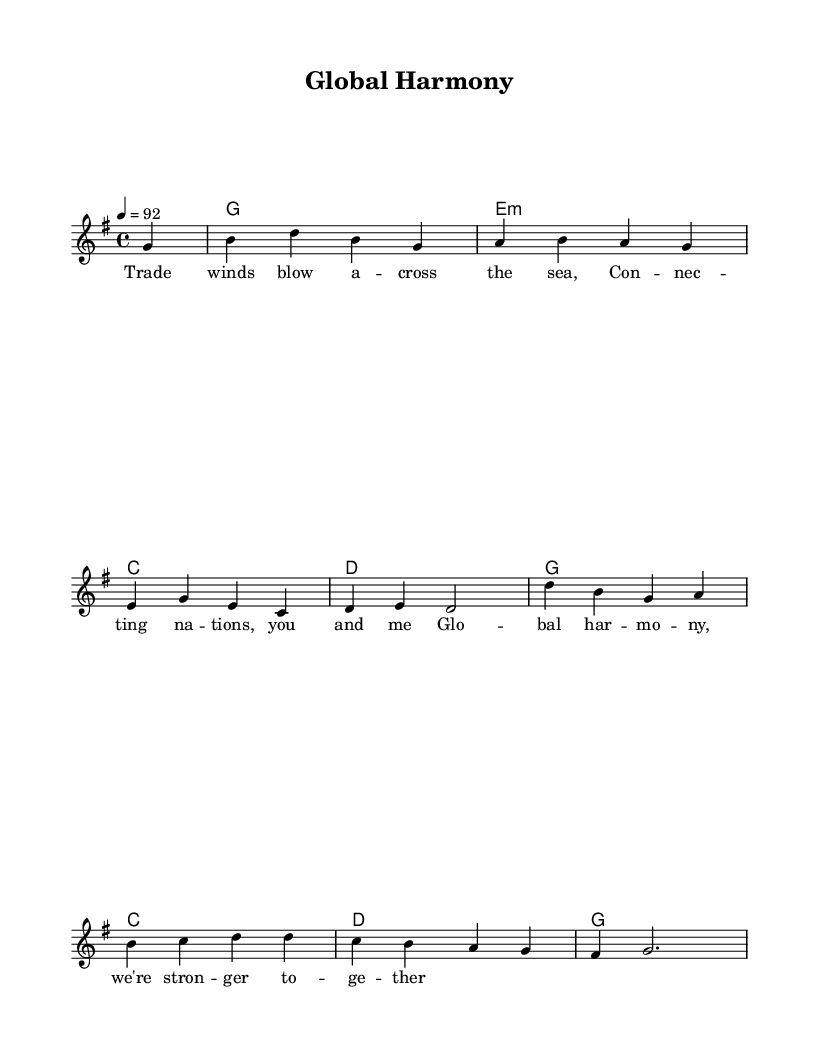What is the key signature of this music? The key signature indicates that the piece is in G major, which has one sharp (F#). This is found at the beginning of the staff, where the sharp sign is placed on the F line of the treble clef.
Answer: G major What is the time signature of this music? The time signature is indicated after the key signature at the beginning of the piece. It shows 4/4, meaning there are four beats in each measure and a quarter note gets one beat.
Answer: 4/4 What is the tempo marking for this piece? The tempo marking is specified in beats per minute and is written at the beginning of the score. It reads "4 = 92", indicating the speed of 92 beats per minute in quarter note beats.
Answer: 92 How many measures are in the melody? By counting the distinct segments separated by the vertical bar lines, we can discern that there are 8 measures in the melody. This can be confirmed by analyzing the grouping of notes and the partials indicated.
Answer: 8 What is the main theme expressed in the lyrics? The lyrics convey a theme of global unity and international cooperation, as indicated by phrases like "Trade winds blow" and "Global harmony." The combination of lyrics with the upbeat reggae style enhances this theme.
Answer: Global unity What chords accompany the melody? The chords are listed underneath the melody in chord symbols. They correspond to G major, E minor, C major, D major, and repeat, reflecting the harmony in the piece's structure.
Answer: G, E minor, C, D What musical genre is this piece? The overall style of the song, characterized by its rhythm and themes of cooperation, aligns with reggae music, which often focuses on social issues and community. This can be inferred from the rhythmic structure and lyrical content.
Answer: Reggae 